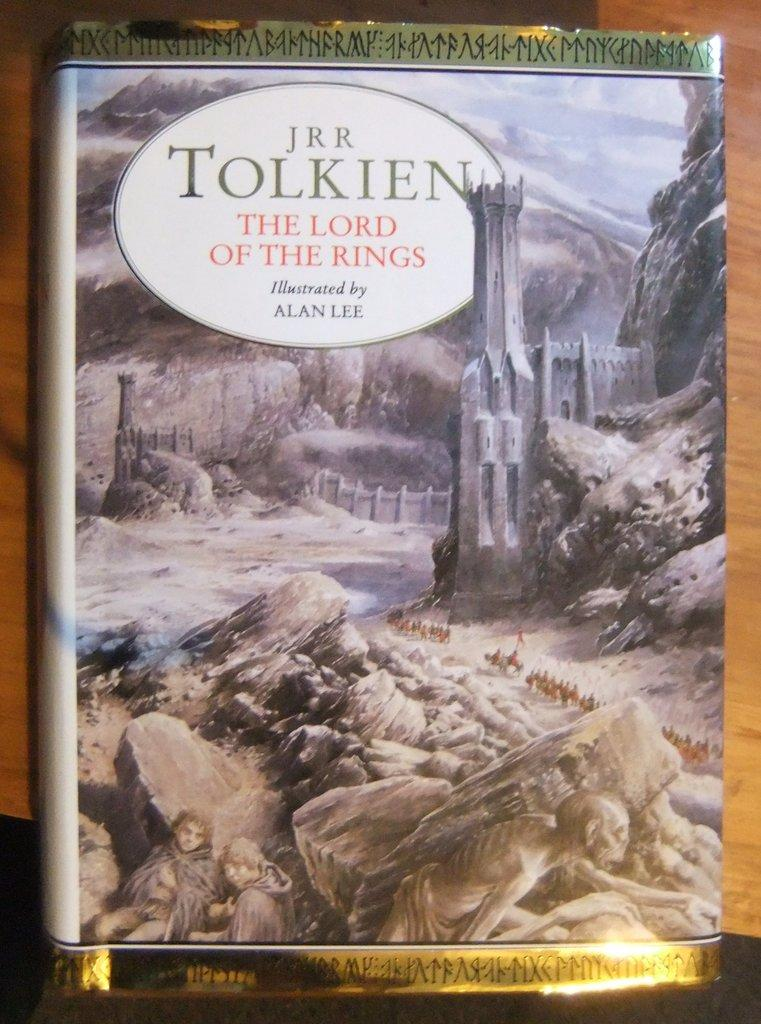What is present in the image that contains text? There is a poster in the image that contains text. Can you describe the text on the poster? The text is at the top of the poster. What type of natural elements can be seen in the image? There are rocks visible in the image. What kind of object can be seen in the background of the image? There appears to be a wooden object in the background of the image. What type of dog can be seen playing with a box of eggnog in the image? There is no dog or box of eggnog present in the image. What type of eggnog-related activity is happening in the image? There is no eggnog or related activity depicted in the image. 